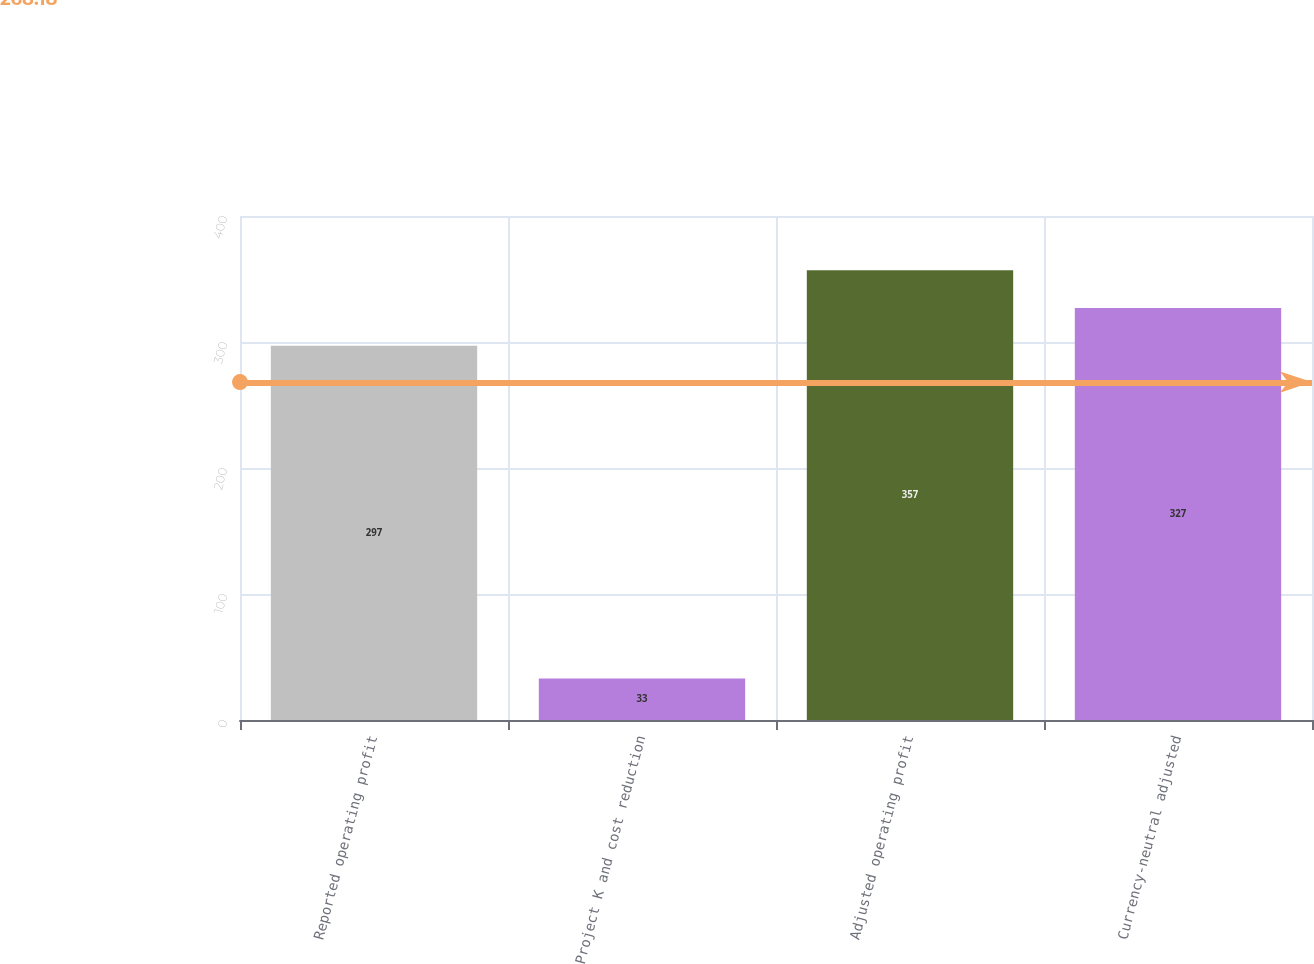Convert chart to OTSL. <chart><loc_0><loc_0><loc_500><loc_500><bar_chart><fcel>Reported operating profit<fcel>Project K and cost reduction<fcel>Adjusted operating profit<fcel>Currency-neutral adjusted<nl><fcel>297<fcel>33<fcel>357<fcel>327<nl></chart> 